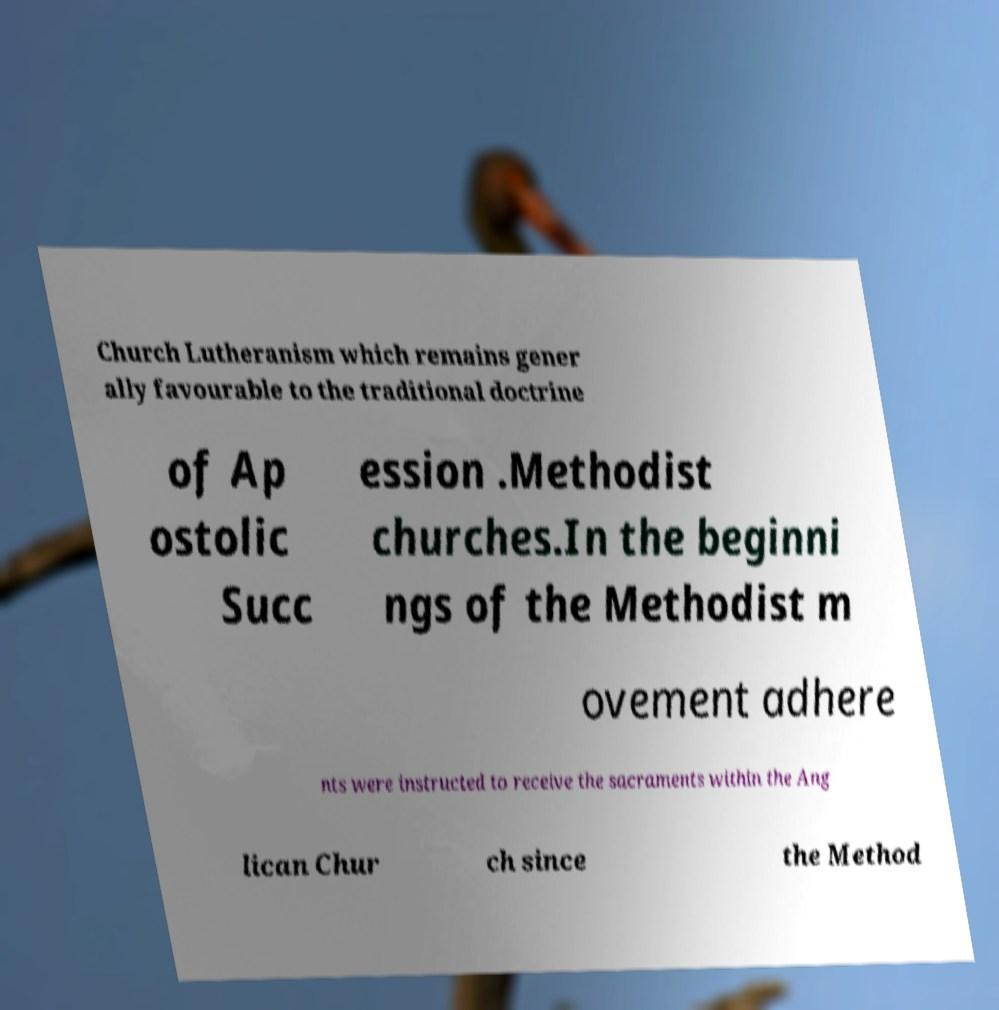Can you read and provide the text displayed in the image?This photo seems to have some interesting text. Can you extract and type it out for me? Church Lutheranism which remains gener ally favourable to the traditional doctrine of Ap ostolic Succ ession .Methodist churches.In the beginni ngs of the Methodist m ovement adhere nts were instructed to receive the sacraments within the Ang lican Chur ch since the Method 